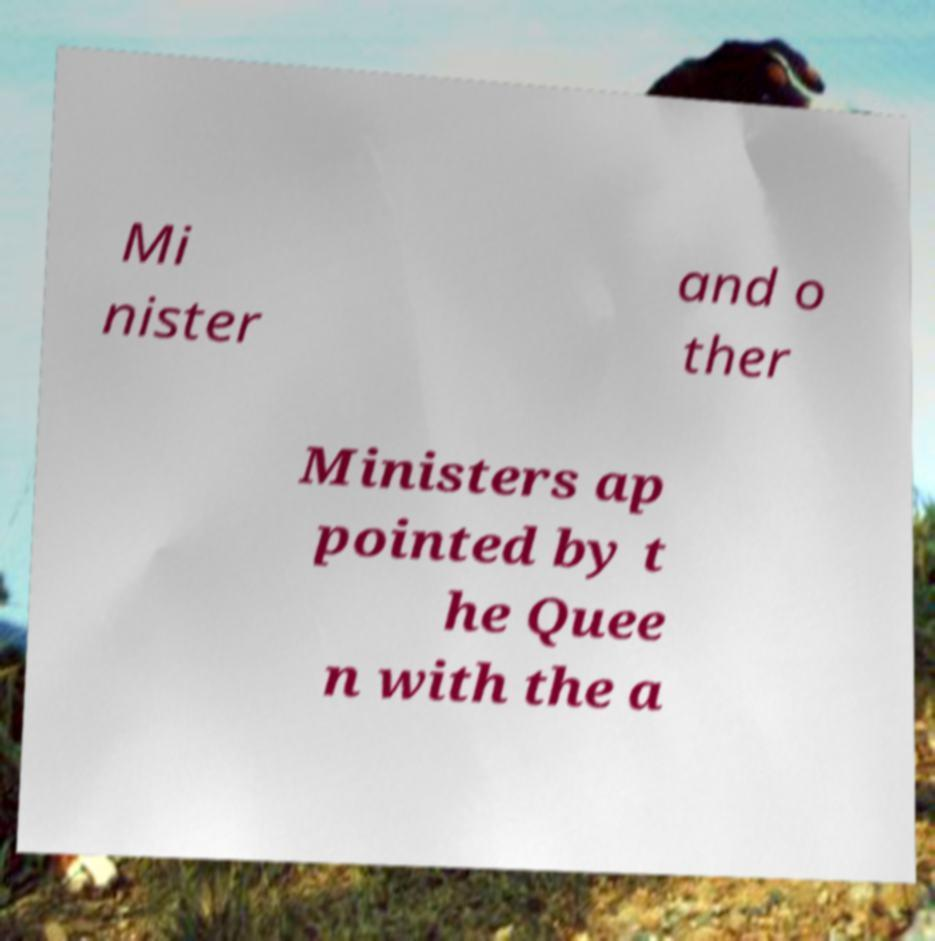For documentation purposes, I need the text within this image transcribed. Could you provide that? Mi nister and o ther Ministers ap pointed by t he Quee n with the a 